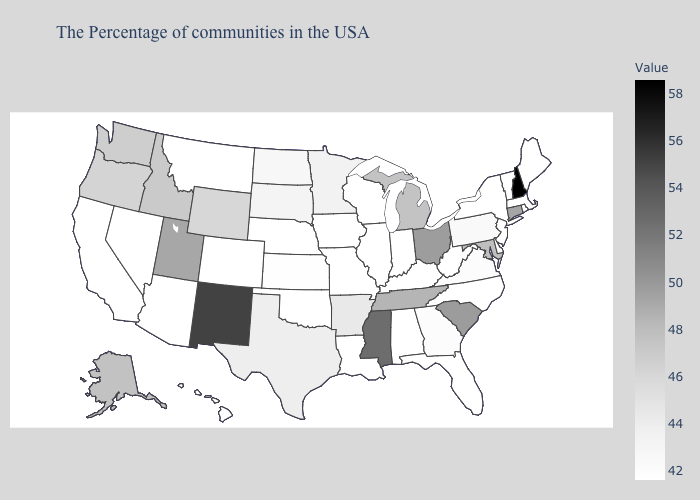Among the states that border Wyoming , which have the lowest value?
Keep it brief. Nebraska, Colorado, Montana. Does the map have missing data?
Short answer required. No. Among the states that border Montana , does Wyoming have the highest value?
Quick response, please. No. Which states hav the highest value in the MidWest?
Answer briefly. Ohio. 